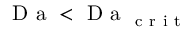Convert formula to latex. <formula><loc_0><loc_0><loc_500><loc_500>D a < D a _ { c r i t }</formula> 